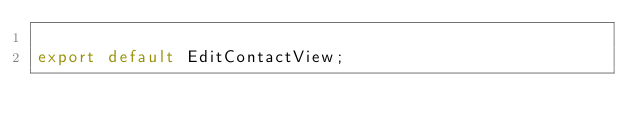Convert code to text. <code><loc_0><loc_0><loc_500><loc_500><_TypeScript_>
export default EditContactView;
</code> 